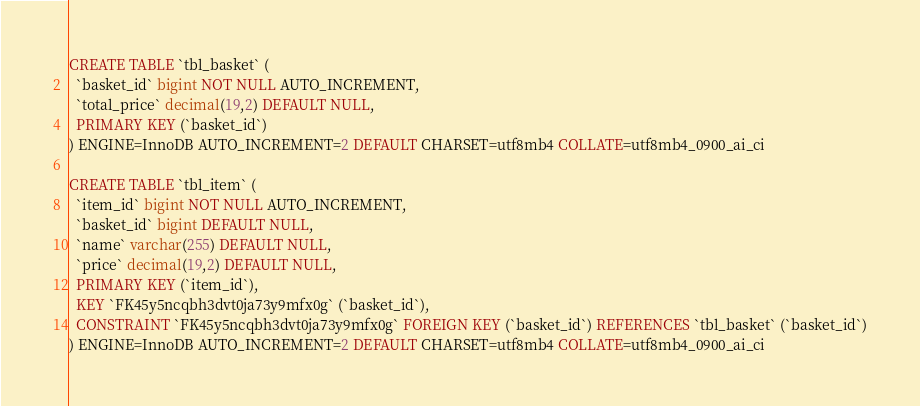Convert code to text. <code><loc_0><loc_0><loc_500><loc_500><_SQL_>CREATE TABLE `tbl_basket` (
  `basket_id` bigint NOT NULL AUTO_INCREMENT,
  `total_price` decimal(19,2) DEFAULT NULL,
  PRIMARY KEY (`basket_id`)
) ENGINE=InnoDB AUTO_INCREMENT=2 DEFAULT CHARSET=utf8mb4 COLLATE=utf8mb4_0900_ai_ci

CREATE TABLE `tbl_item` (
  `item_id` bigint NOT NULL AUTO_INCREMENT,
  `basket_id` bigint DEFAULT NULL,
  `name` varchar(255) DEFAULT NULL,
  `price` decimal(19,2) DEFAULT NULL,
  PRIMARY KEY (`item_id`),
  KEY `FK45y5ncqbh3dvt0ja73y9mfx0g` (`basket_id`),
  CONSTRAINT `FK45y5ncqbh3dvt0ja73y9mfx0g` FOREIGN KEY (`basket_id`) REFERENCES `tbl_basket` (`basket_id`)
) ENGINE=InnoDB AUTO_INCREMENT=2 DEFAULT CHARSET=utf8mb4 COLLATE=utf8mb4_0900_ai_ci</code> 